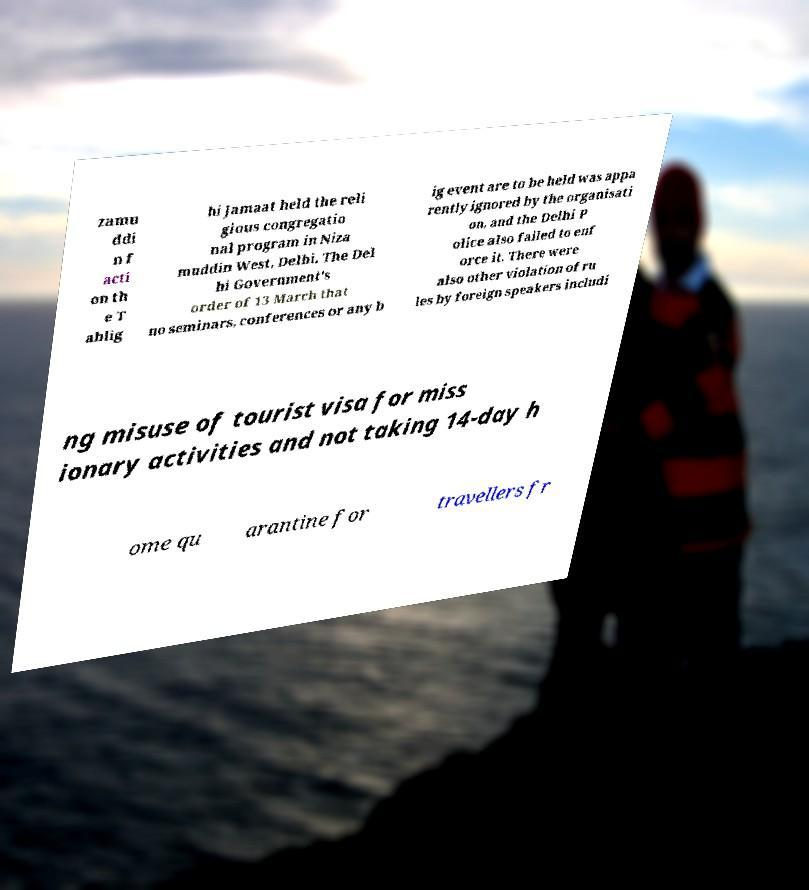Could you extract and type out the text from this image? zamu ddi n f acti on th e T ablig hi Jamaat held the reli gious congregatio nal program in Niza muddin West, Delhi. The Del hi Government's order of 13 March that no seminars, conferences or any b ig event are to be held was appa rently ignored by the organisati on, and the Delhi P olice also failed to enf orce it. There were also other violation of ru les by foreign speakers includi ng misuse of tourist visa for miss ionary activities and not taking 14-day h ome qu arantine for travellers fr 